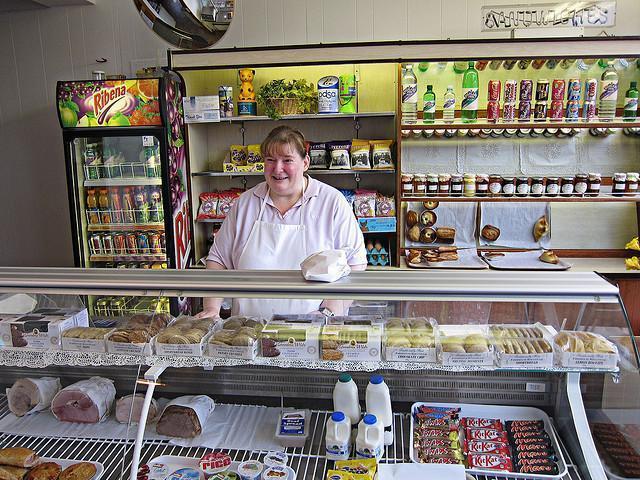How many people are working?
Give a very brief answer. 1. How many people are visible?
Give a very brief answer. 1. 